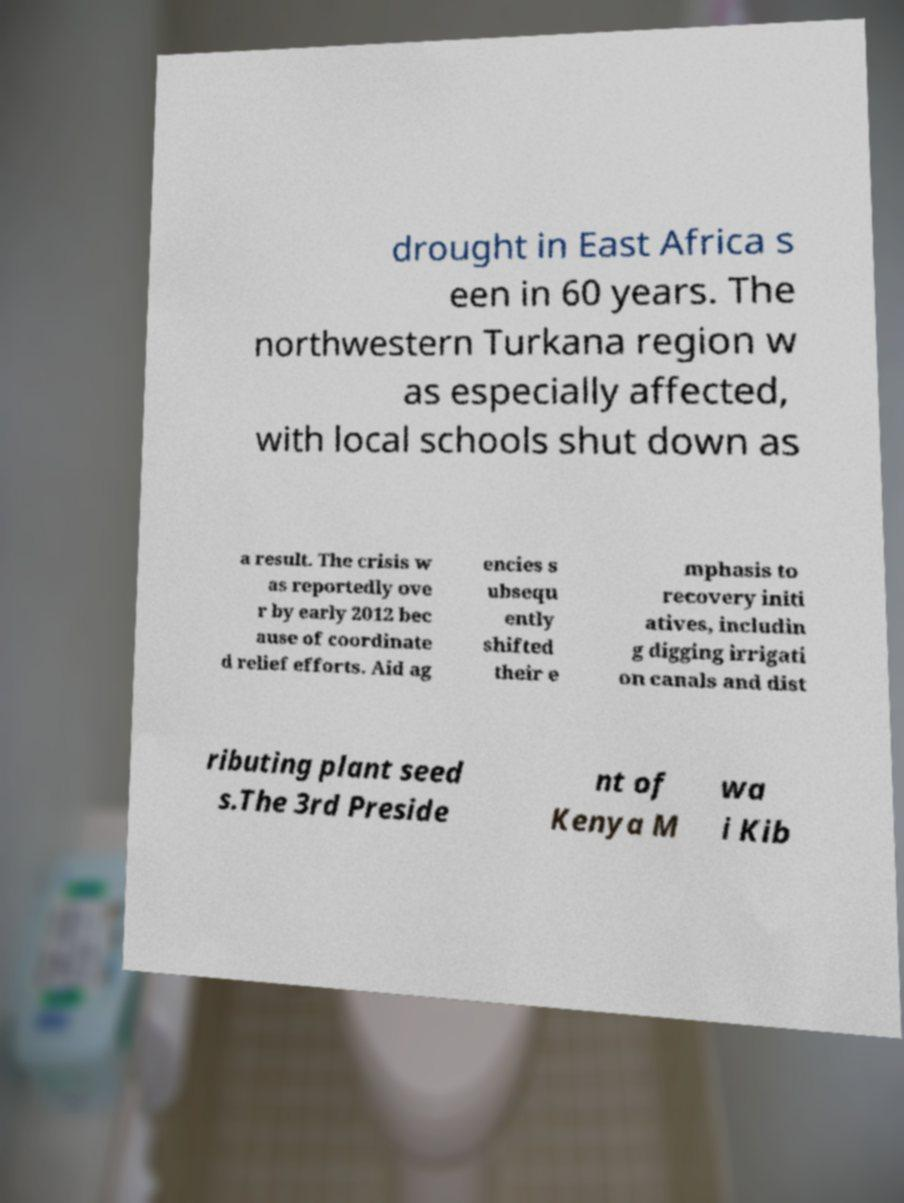For documentation purposes, I need the text within this image transcribed. Could you provide that? drought in East Africa s een in 60 years. The northwestern Turkana region w as especially affected, with local schools shut down as a result. The crisis w as reportedly ove r by early 2012 bec ause of coordinate d relief efforts. Aid ag encies s ubsequ ently shifted their e mphasis to recovery initi atives, includin g digging irrigati on canals and dist ributing plant seed s.The 3rd Preside nt of Kenya M wa i Kib 